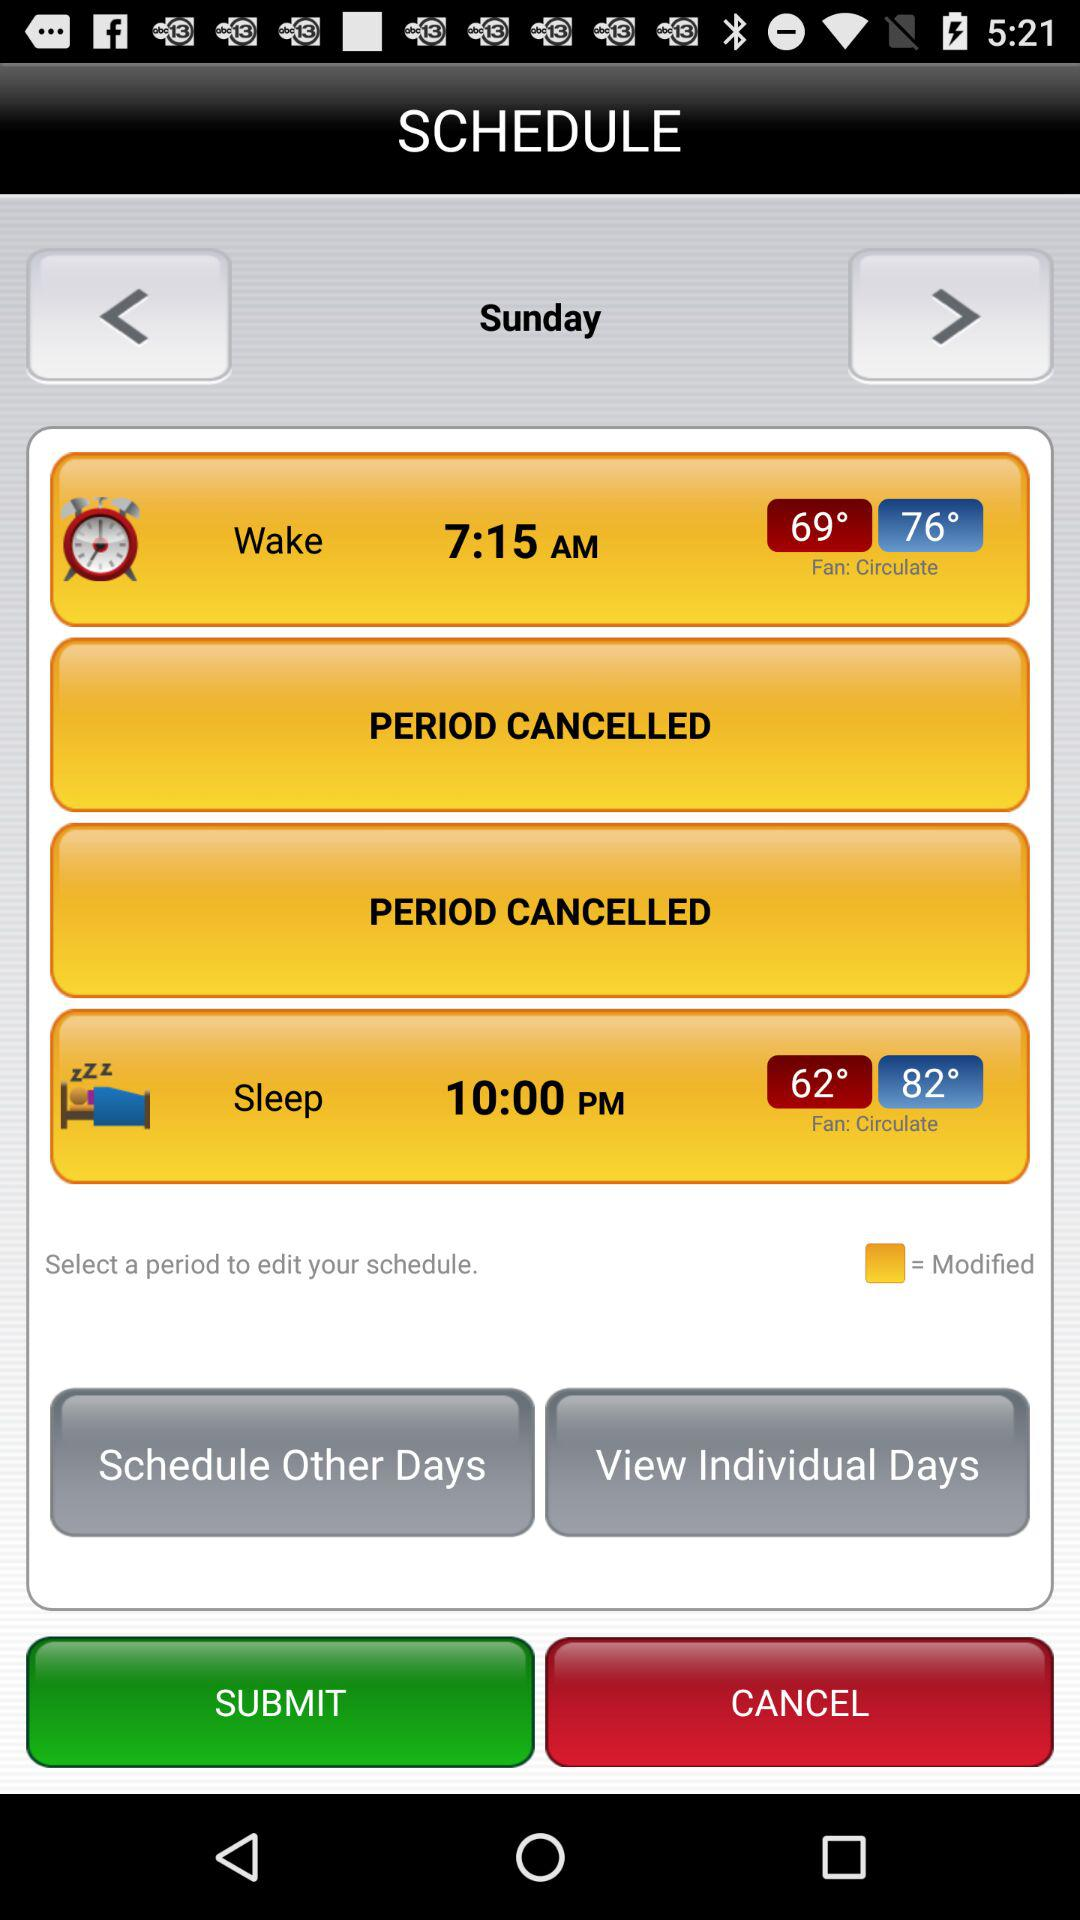What is the weekday of the schedule? The day is Sunday. 